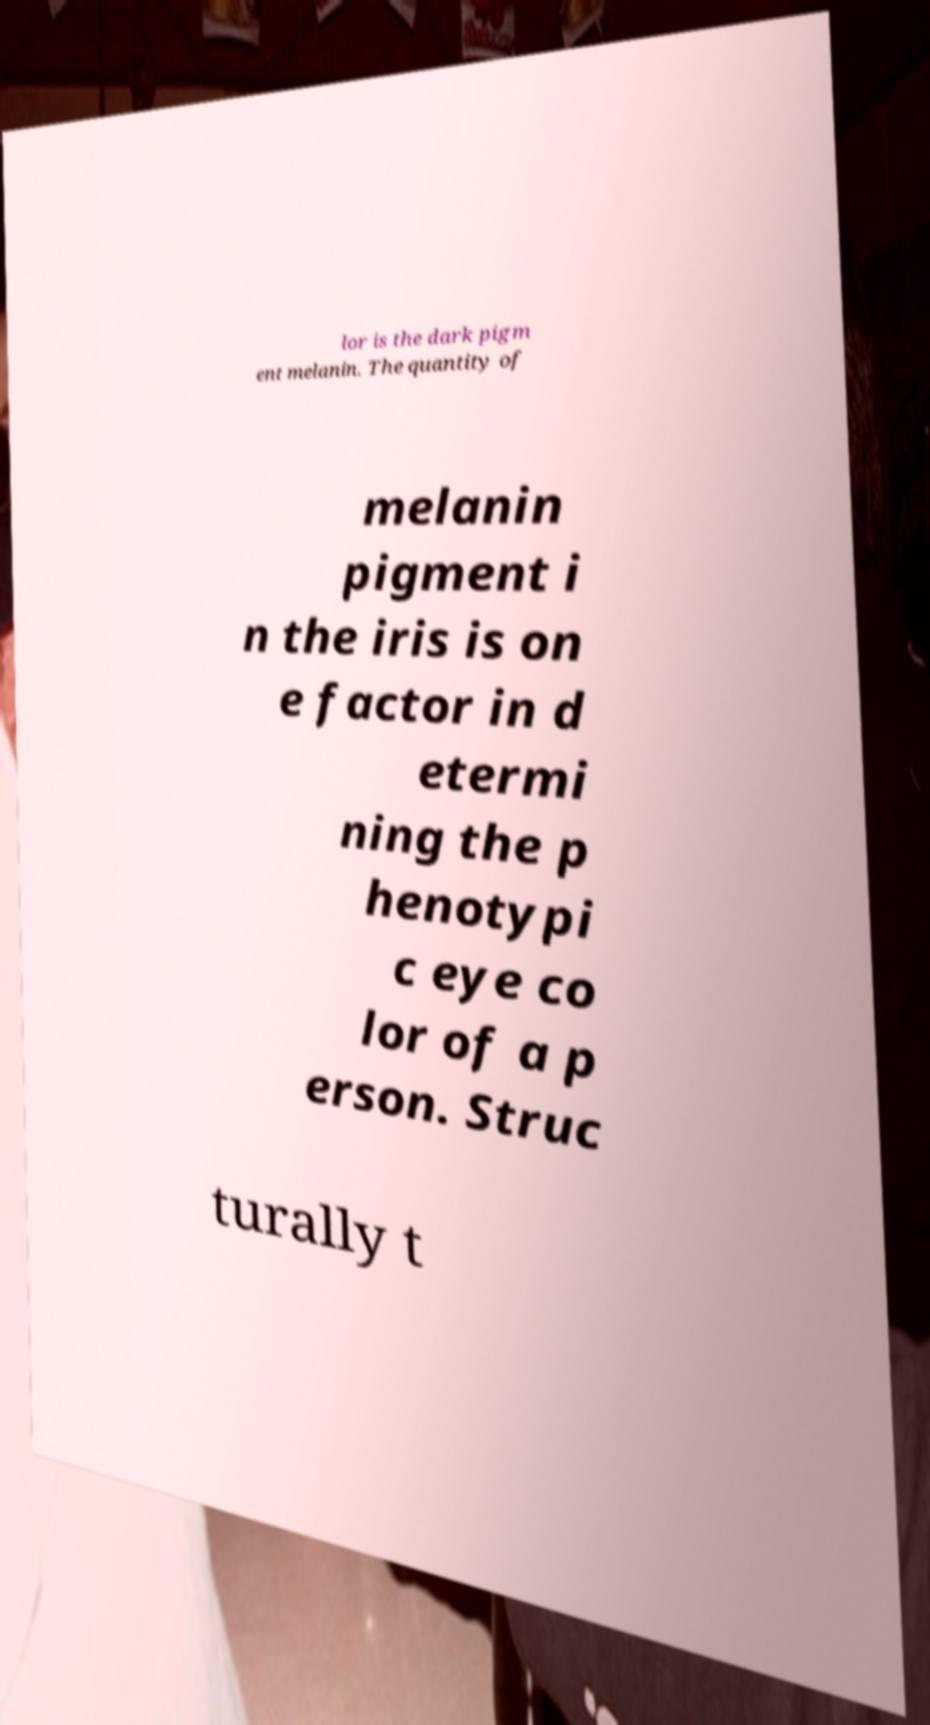There's text embedded in this image that I need extracted. Can you transcribe it verbatim? lor is the dark pigm ent melanin. The quantity of melanin pigment i n the iris is on e factor in d etermi ning the p henotypi c eye co lor of a p erson. Struc turally t 